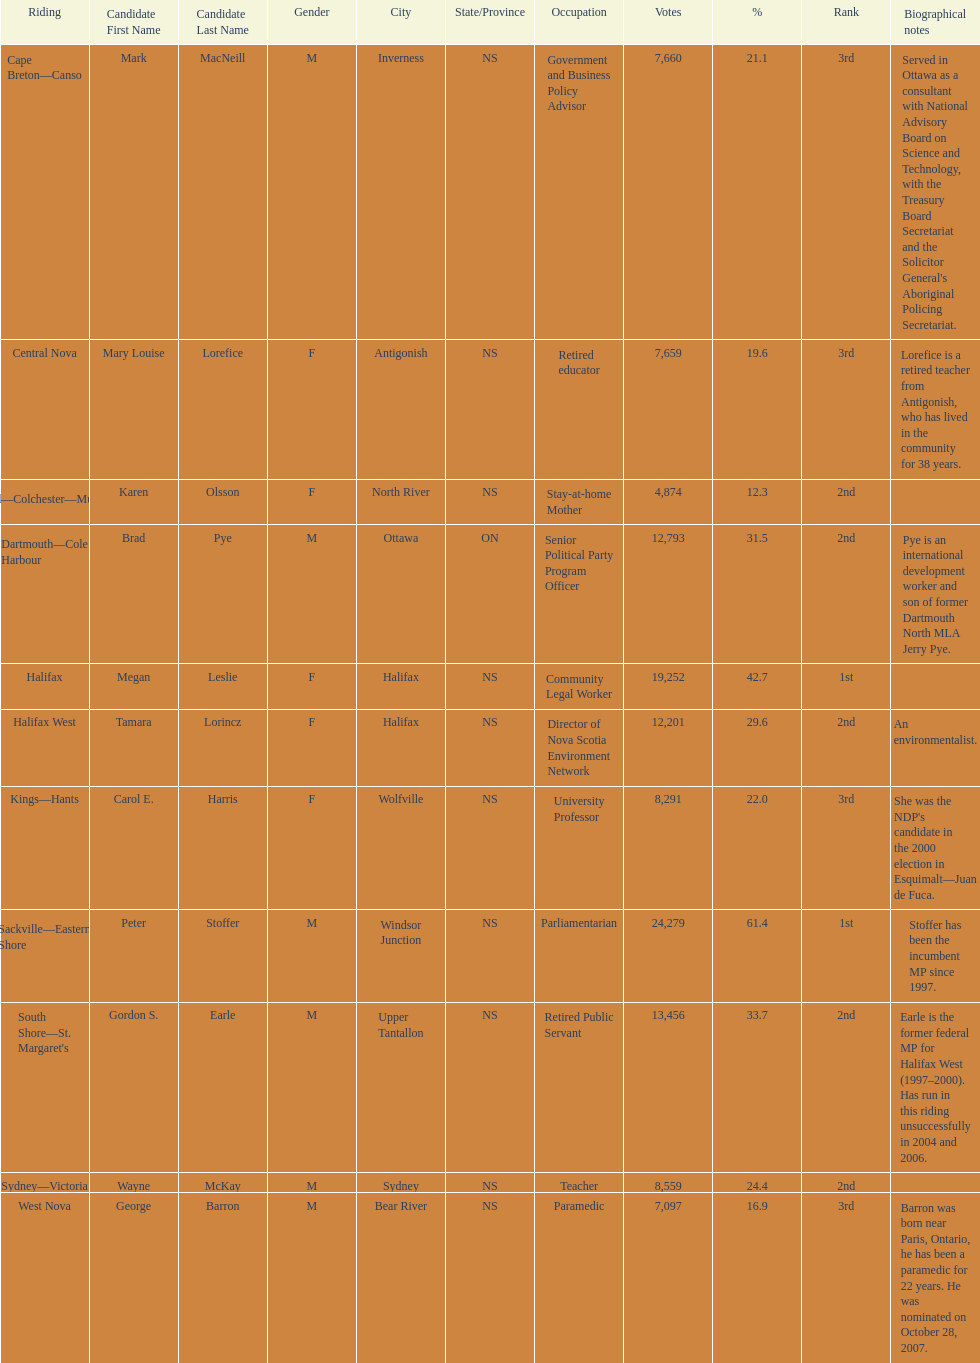What is the first riding? Cape Breton-Canso. 